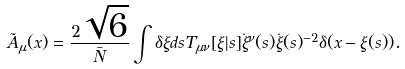Convert formula to latex. <formula><loc_0><loc_0><loc_500><loc_500>\tilde { A } _ { \mu } ( x ) = \frac { 2 \sqrt { 6 } } { \bar { N } } \int \delta \xi d s T _ { \mu \nu } [ \xi | s ] \dot { \xi } ^ { \nu } ( s ) \dot { \xi } ( s ) ^ { - 2 } \delta ( x - \xi ( s ) ) .</formula> 